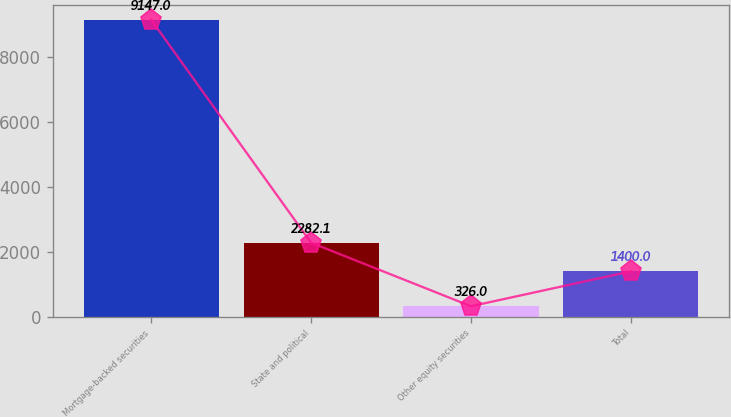Convert chart. <chart><loc_0><loc_0><loc_500><loc_500><bar_chart><fcel>Mortgage-backed securities<fcel>State and political<fcel>Other equity securities<fcel>Total<nl><fcel>9147<fcel>2282.1<fcel>326<fcel>1400<nl></chart> 